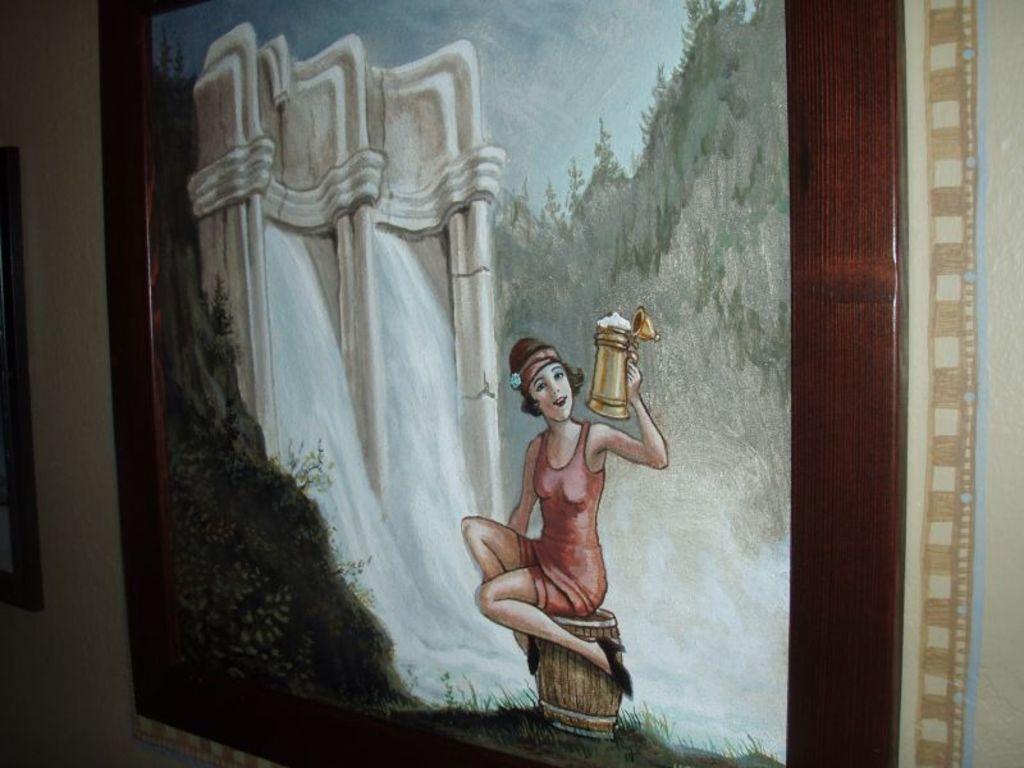Please provide a concise description of this image. In this image I can see a painting frame on the wall. I can see this painting contains picture of a woman, grass, waterfalls, the sky and I can see the woman is holding a golden colour thing. 